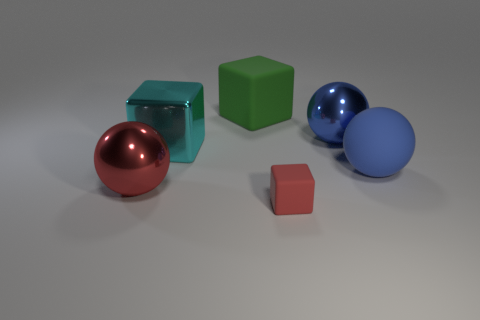The thing that is in front of the shiny sphere to the left of the red object that is in front of the large red metal object is what color?
Make the answer very short. Red. What color is the large ball that is the same material as the big red thing?
Provide a short and direct response. Blue. How many blue blocks are made of the same material as the green cube?
Give a very brief answer. 0. Do the blue thing behind the cyan metallic thing and the red metal ball have the same size?
Offer a very short reply. Yes. What is the color of the rubber cube that is the same size as the cyan metal object?
Provide a short and direct response. Green. How many large balls are behind the green object?
Your answer should be very brief. 0. Is there a purple matte block?
Offer a terse response. No. There is a blue sphere in front of the big shiny ball that is behind the large sphere that is to the left of the small red rubber object; what is its size?
Offer a terse response. Large. What number of other objects are the same size as the red matte object?
Provide a short and direct response. 0. How big is the shiny ball that is on the right side of the red rubber cube?
Provide a short and direct response. Large. 